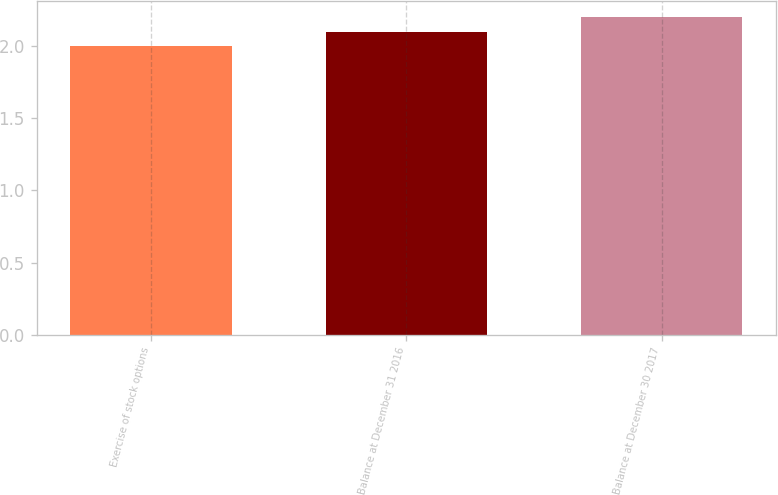<chart> <loc_0><loc_0><loc_500><loc_500><bar_chart><fcel>Exercise of stock options<fcel>Balance at December 31 2016<fcel>Balance at December 30 2017<nl><fcel>2<fcel>2.1<fcel>2.2<nl></chart> 